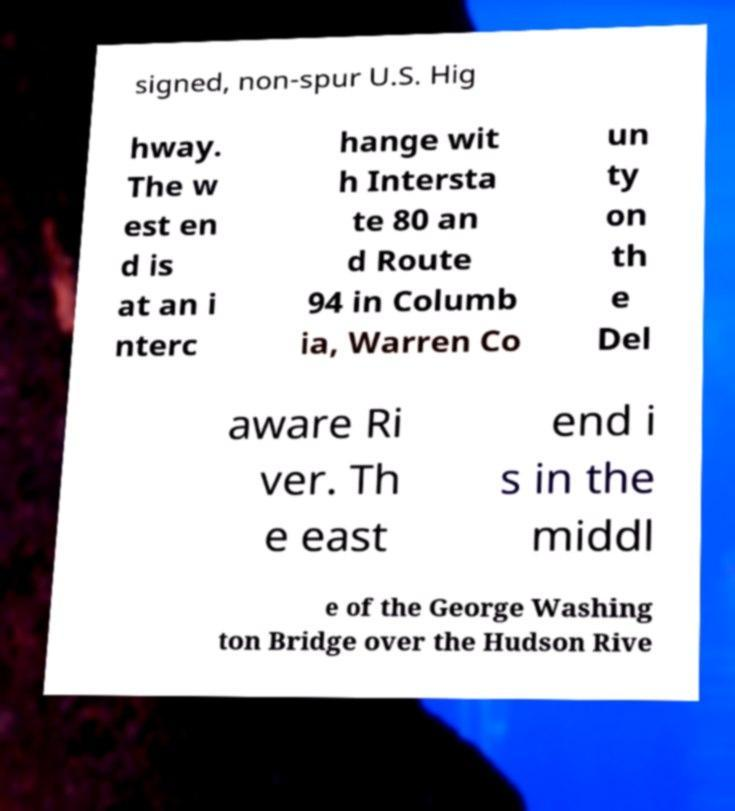Can you accurately transcribe the text from the provided image for me? signed, non-spur U.S. Hig hway. The w est en d is at an i nterc hange wit h Intersta te 80 an d Route 94 in Columb ia, Warren Co un ty on th e Del aware Ri ver. Th e east end i s in the middl e of the George Washing ton Bridge over the Hudson Rive 